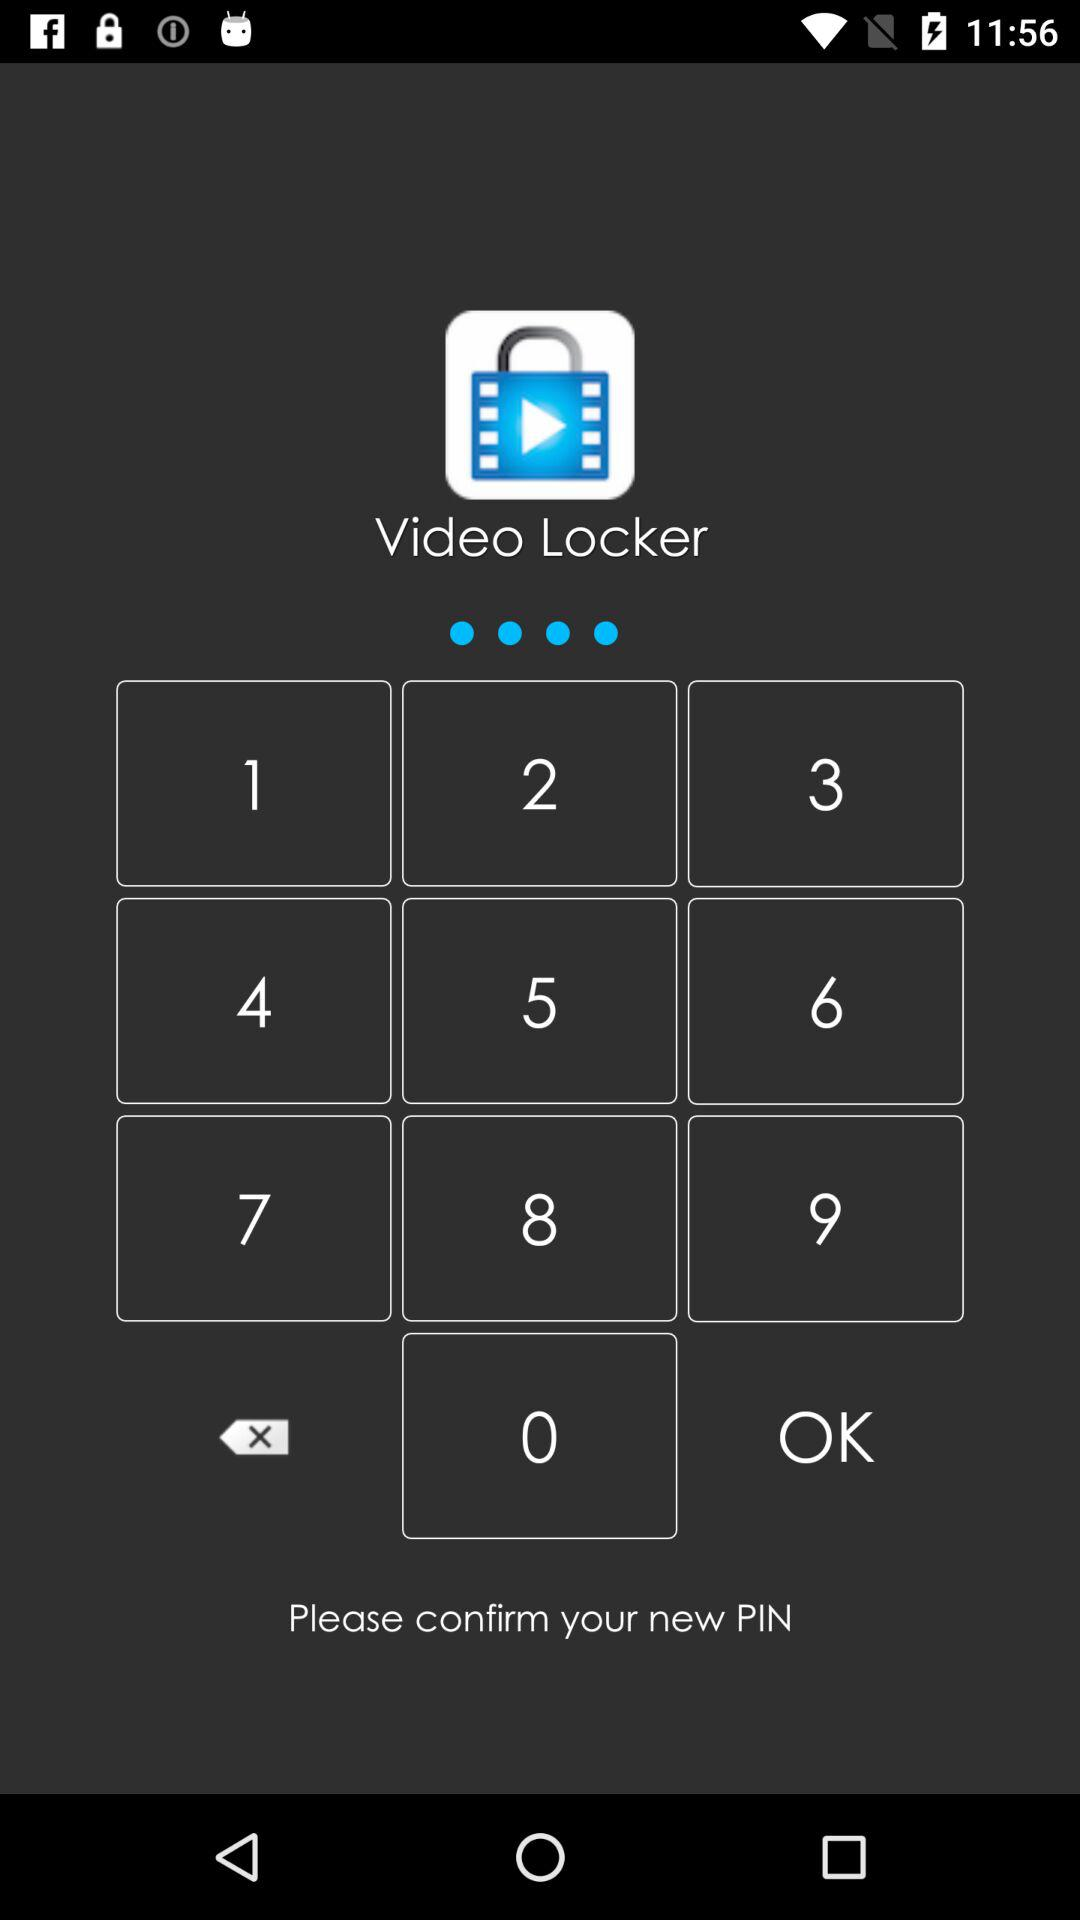What is the name of the application? The name of the application is "Video Locker". 